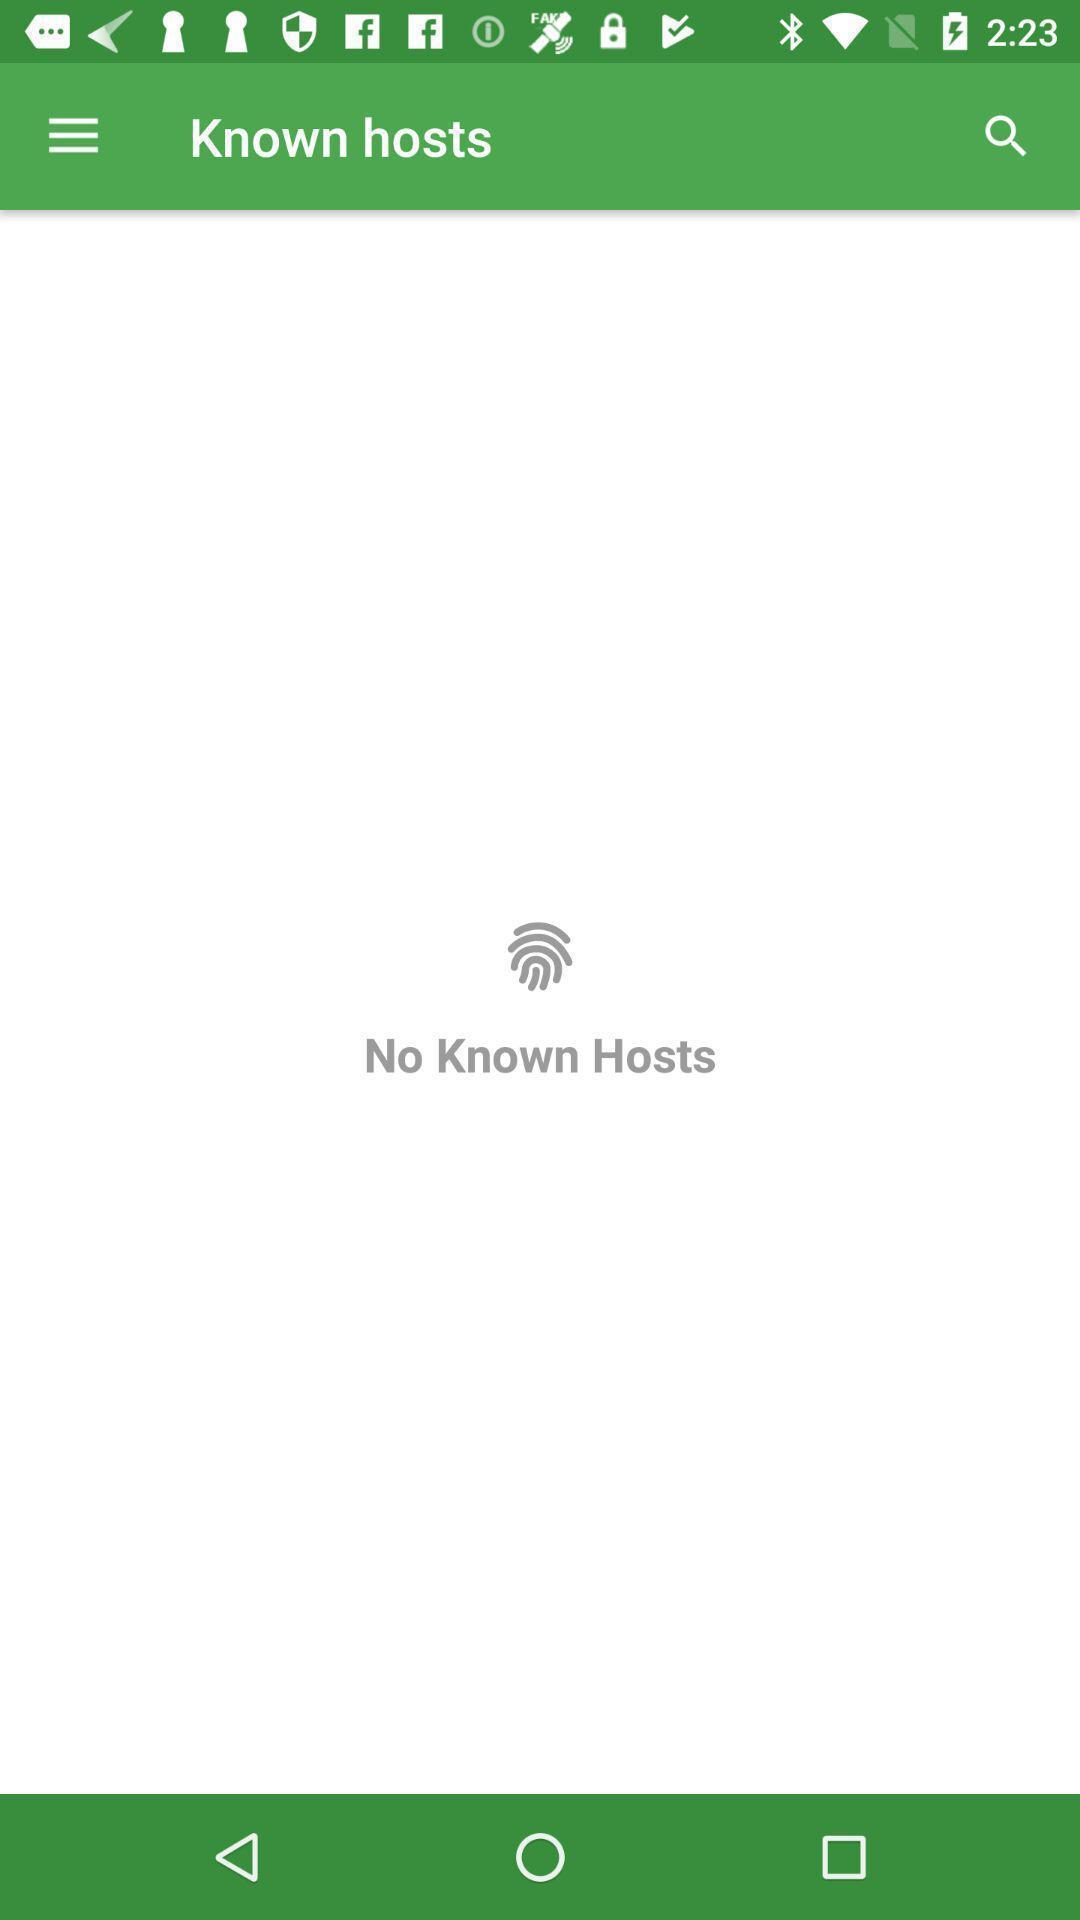Describe this image in words. Showing known hosts page. 